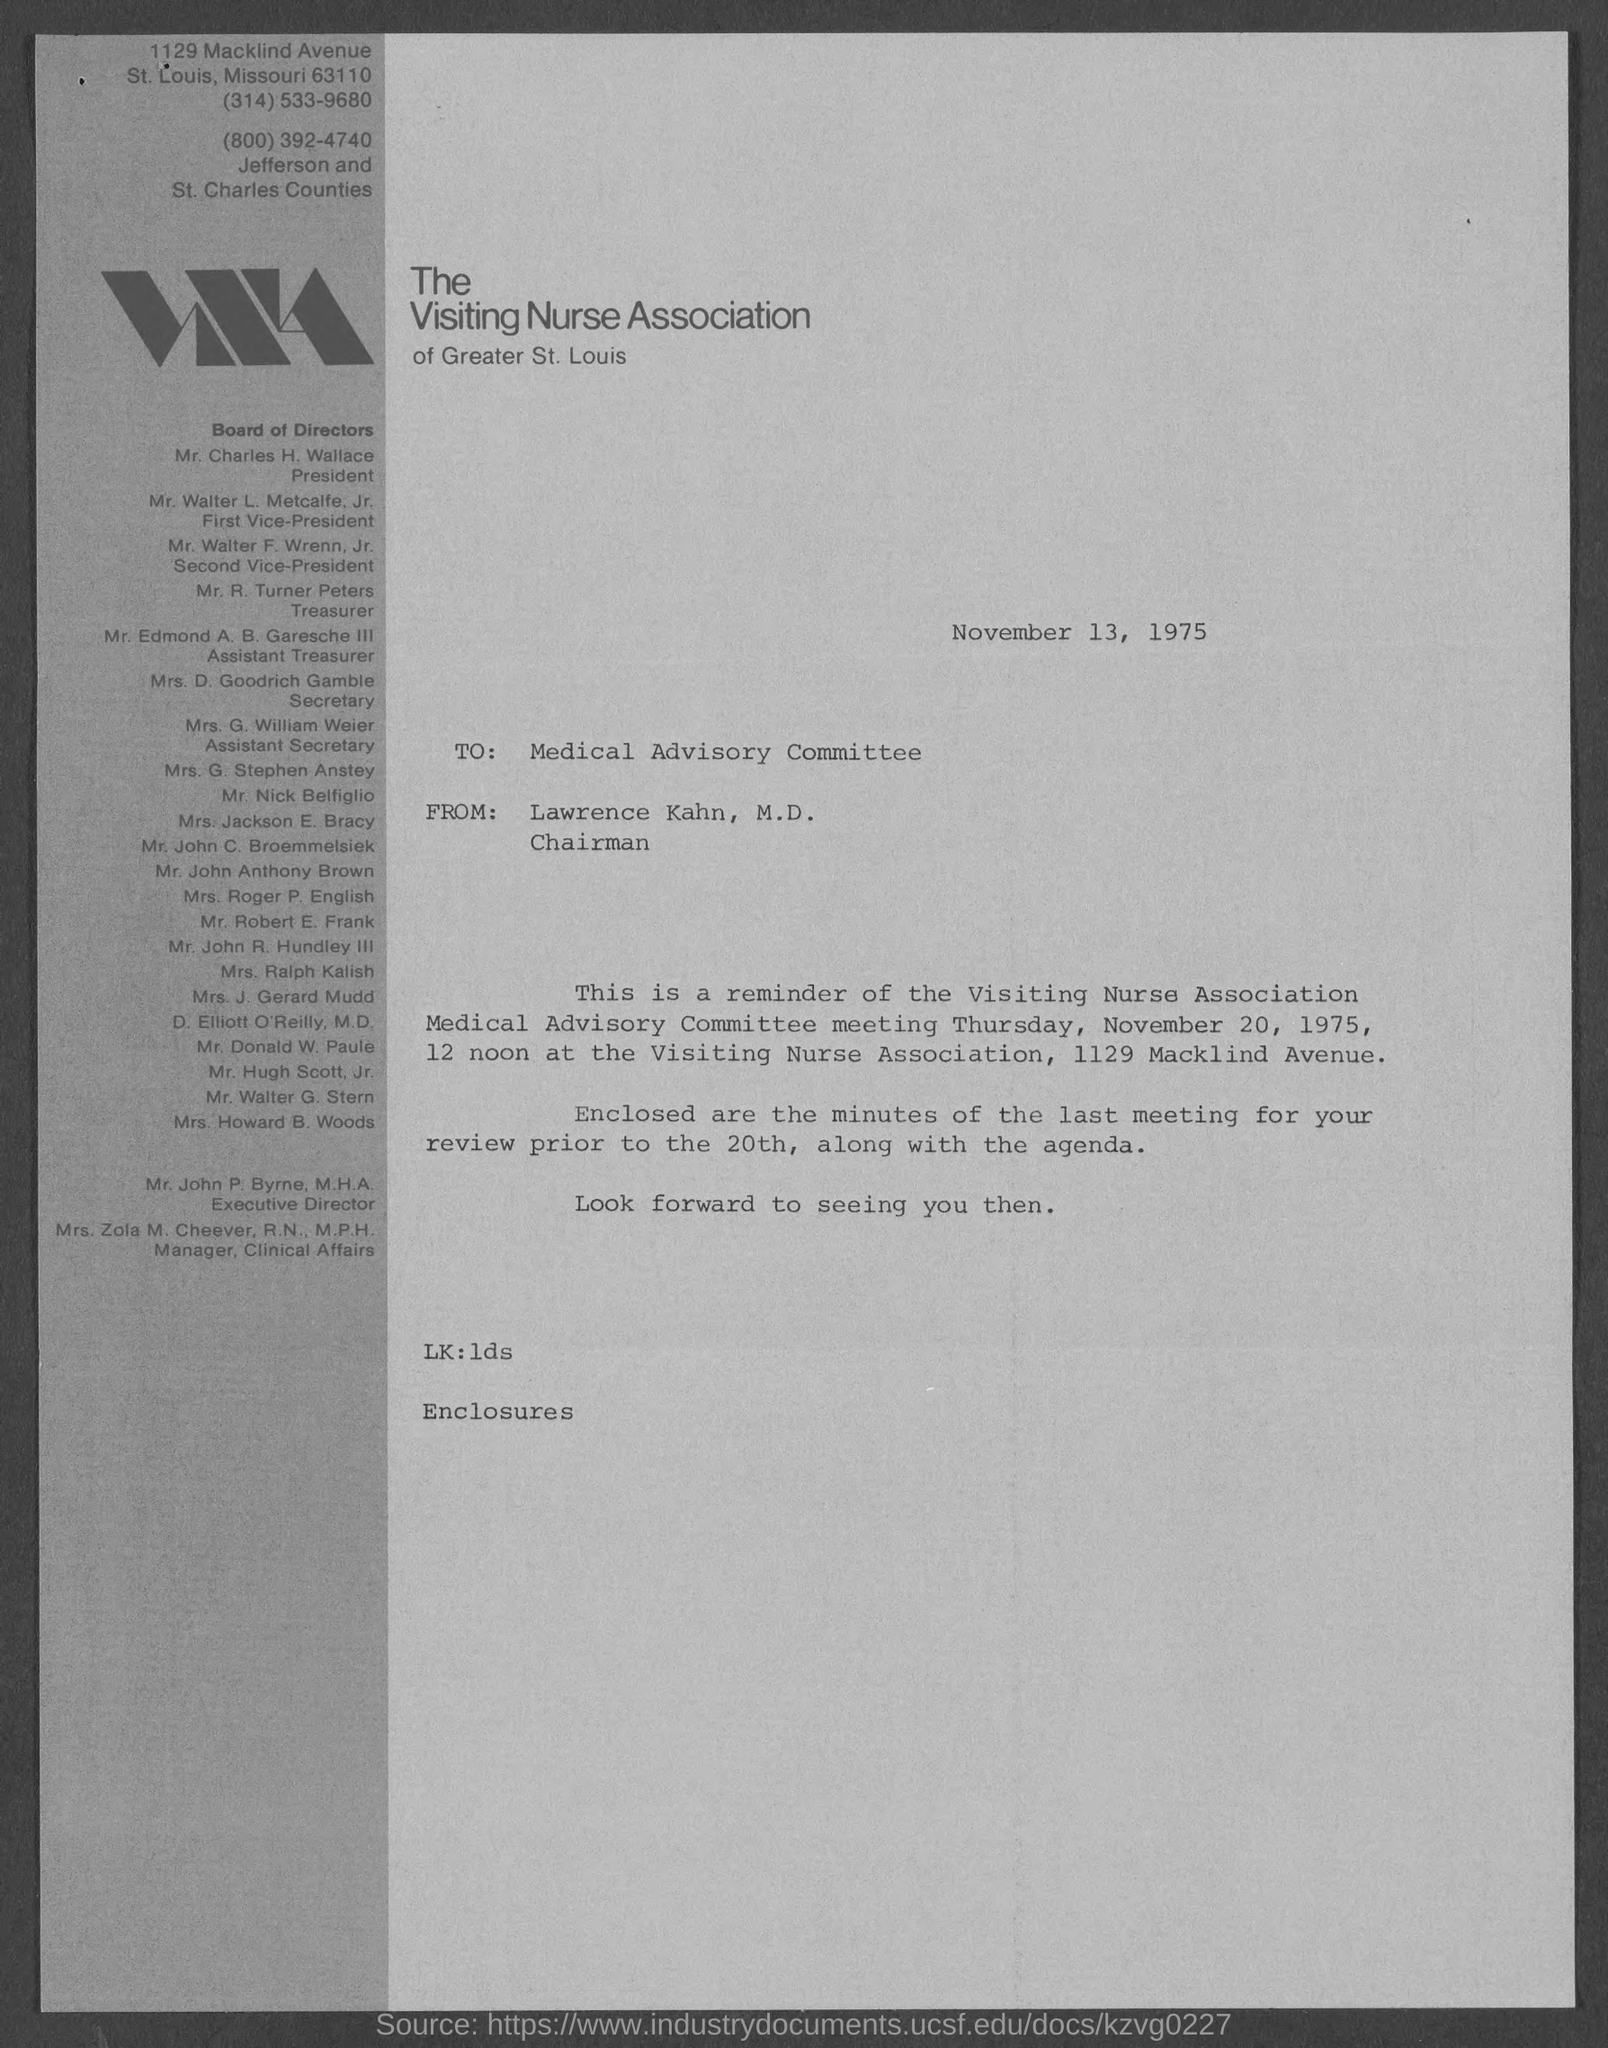Highlight a few significant elements in this photo. The document is dated November 13, 1975. The president is Mr. Charles H. Wallace. The letter is addressed to the Medical Advisory Committee. The Visiting Nurse Association is mentioned. The letter is from Lawrence Kahn, M.D. 